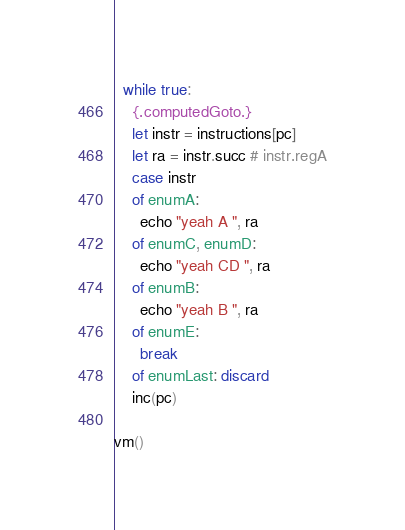Convert code to text. <code><loc_0><loc_0><loc_500><loc_500><_Nim_>  while true:
    {.computedGoto.}
    let instr = instructions[pc]
    let ra = instr.succ # instr.regA
    case instr
    of enumA:
      echo "yeah A ", ra
    of enumC, enumD:
      echo "yeah CD ", ra
    of enumB:
      echo "yeah B ", ra
    of enumE:
      break
    of enumLast: discard
    inc(pc)

vm()
</code> 